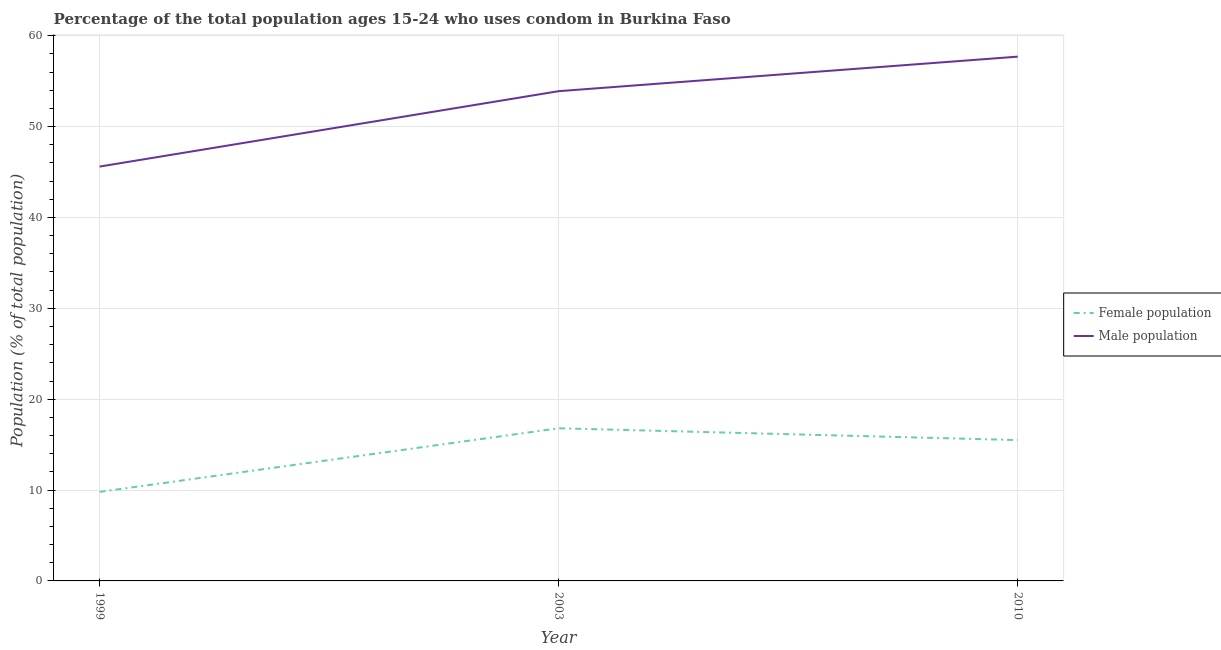What is the female population in 2010?
Offer a very short reply. 15.5. Across all years, what is the maximum male population?
Your answer should be compact. 57.7. Across all years, what is the minimum male population?
Your response must be concise. 45.6. In which year was the male population minimum?
Your response must be concise. 1999. What is the total male population in the graph?
Give a very brief answer. 157.2. What is the difference between the female population in 2003 and the male population in 2010?
Ensure brevity in your answer.  -40.9. What is the average female population per year?
Provide a short and direct response. 14.03. In the year 1999, what is the difference between the female population and male population?
Your response must be concise. -35.8. In how many years, is the male population greater than 12 %?
Offer a very short reply. 3. What is the ratio of the male population in 1999 to that in 2003?
Provide a short and direct response. 0.85. Is the male population in 1999 less than that in 2010?
Give a very brief answer. Yes. What is the difference between the highest and the second highest male population?
Your answer should be very brief. 3.8. In how many years, is the female population greater than the average female population taken over all years?
Ensure brevity in your answer.  2. Is the sum of the female population in 1999 and 2003 greater than the maximum male population across all years?
Your answer should be very brief. No. Is the male population strictly greater than the female population over the years?
Give a very brief answer. Yes. How many lines are there?
Provide a succinct answer. 2. How many years are there in the graph?
Your answer should be compact. 3. Are the values on the major ticks of Y-axis written in scientific E-notation?
Offer a terse response. No. What is the title of the graph?
Provide a short and direct response. Percentage of the total population ages 15-24 who uses condom in Burkina Faso. Does "Resident" appear as one of the legend labels in the graph?
Offer a terse response. No. What is the label or title of the X-axis?
Keep it short and to the point. Year. What is the label or title of the Y-axis?
Your response must be concise. Population (% of total population) . What is the Population (% of total population)  in Female population in 1999?
Ensure brevity in your answer.  9.8. What is the Population (% of total population)  of Male population in 1999?
Offer a very short reply. 45.6. What is the Population (% of total population)  of Female population in 2003?
Your answer should be very brief. 16.8. What is the Population (% of total population)  in Male population in 2003?
Ensure brevity in your answer.  53.9. What is the Population (% of total population)  of Male population in 2010?
Make the answer very short. 57.7. Across all years, what is the maximum Population (% of total population)  in Male population?
Ensure brevity in your answer.  57.7. Across all years, what is the minimum Population (% of total population)  in Female population?
Keep it short and to the point. 9.8. Across all years, what is the minimum Population (% of total population)  of Male population?
Make the answer very short. 45.6. What is the total Population (% of total population)  of Female population in the graph?
Keep it short and to the point. 42.1. What is the total Population (% of total population)  in Male population in the graph?
Make the answer very short. 157.2. What is the difference between the Population (% of total population)  in Female population in 1999 and that in 2003?
Your answer should be compact. -7. What is the difference between the Population (% of total population)  in Female population in 2003 and that in 2010?
Your answer should be compact. 1.3. What is the difference between the Population (% of total population)  of Female population in 1999 and the Population (% of total population)  of Male population in 2003?
Make the answer very short. -44.1. What is the difference between the Population (% of total population)  in Female population in 1999 and the Population (% of total population)  in Male population in 2010?
Provide a short and direct response. -47.9. What is the difference between the Population (% of total population)  of Female population in 2003 and the Population (% of total population)  of Male population in 2010?
Keep it short and to the point. -40.9. What is the average Population (% of total population)  in Female population per year?
Make the answer very short. 14.03. What is the average Population (% of total population)  in Male population per year?
Your answer should be very brief. 52.4. In the year 1999, what is the difference between the Population (% of total population)  of Female population and Population (% of total population)  of Male population?
Offer a terse response. -35.8. In the year 2003, what is the difference between the Population (% of total population)  in Female population and Population (% of total population)  in Male population?
Your answer should be compact. -37.1. In the year 2010, what is the difference between the Population (% of total population)  of Female population and Population (% of total population)  of Male population?
Ensure brevity in your answer.  -42.2. What is the ratio of the Population (% of total population)  in Female population in 1999 to that in 2003?
Offer a terse response. 0.58. What is the ratio of the Population (% of total population)  in Male population in 1999 to that in 2003?
Make the answer very short. 0.85. What is the ratio of the Population (% of total population)  in Female population in 1999 to that in 2010?
Your answer should be compact. 0.63. What is the ratio of the Population (% of total population)  in Male population in 1999 to that in 2010?
Offer a very short reply. 0.79. What is the ratio of the Population (% of total population)  in Female population in 2003 to that in 2010?
Provide a short and direct response. 1.08. What is the ratio of the Population (% of total population)  of Male population in 2003 to that in 2010?
Provide a short and direct response. 0.93. What is the difference between the highest and the second highest Population (% of total population)  in Male population?
Keep it short and to the point. 3.8. 